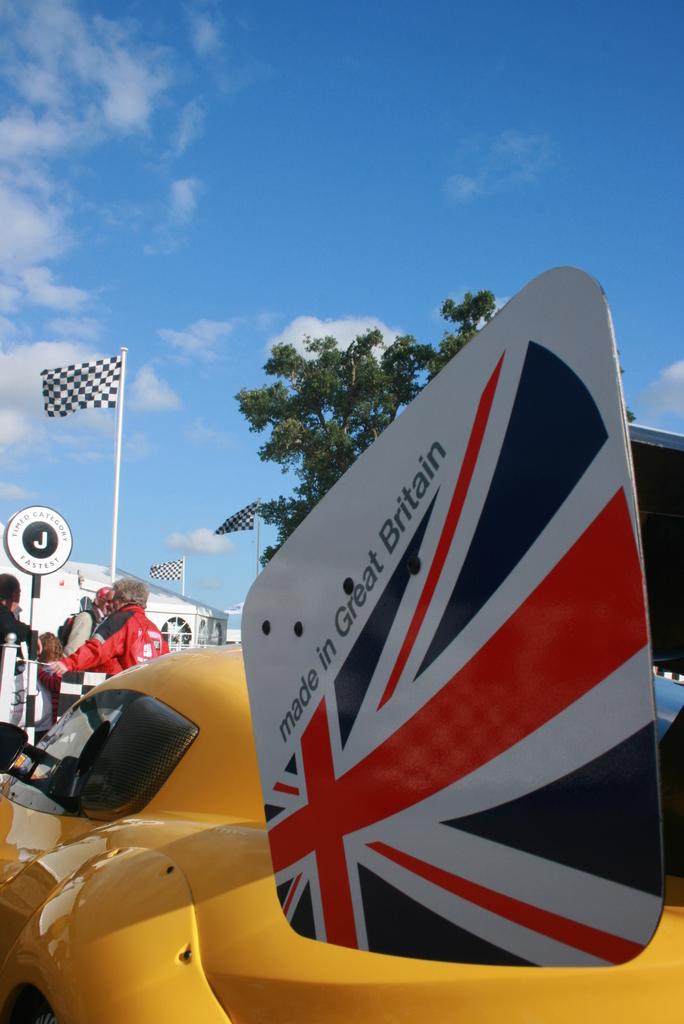What is the object that is "made in britain"?
Your response must be concise. Answering does not require reading text in the image. 